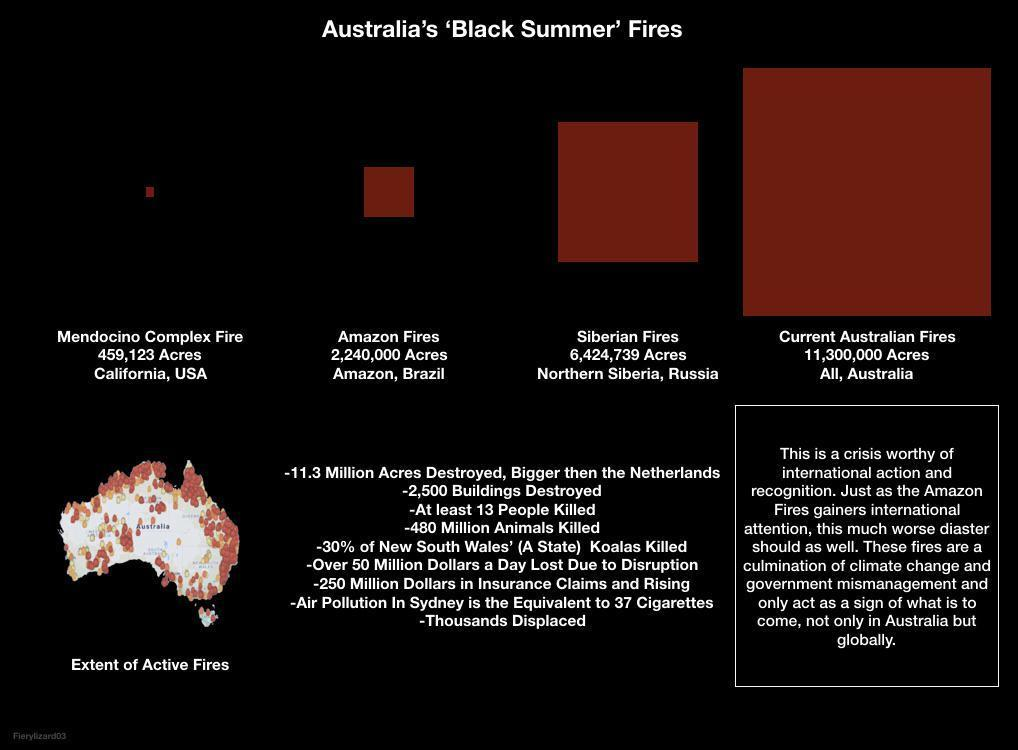Which fire incident happened in California?
Answer the question with a short phrase. Mendocino Complex Fire How much land was destroyed by fire in Northern Siberia? 6,424,739 Acres In which country was 11,300,000 Acres of land destroyed by fires? Australia How many acres of land was destroyed by Amazon Fires? 2,240,000 Acres 